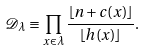Convert formula to latex. <formula><loc_0><loc_0><loc_500><loc_500>\mathcal { D } _ { \lambda } \equiv \prod _ { x \in \lambda } \frac { \lfloor n + c ( x ) \rfloor } { \lfloor h ( x ) \rfloor } .</formula> 